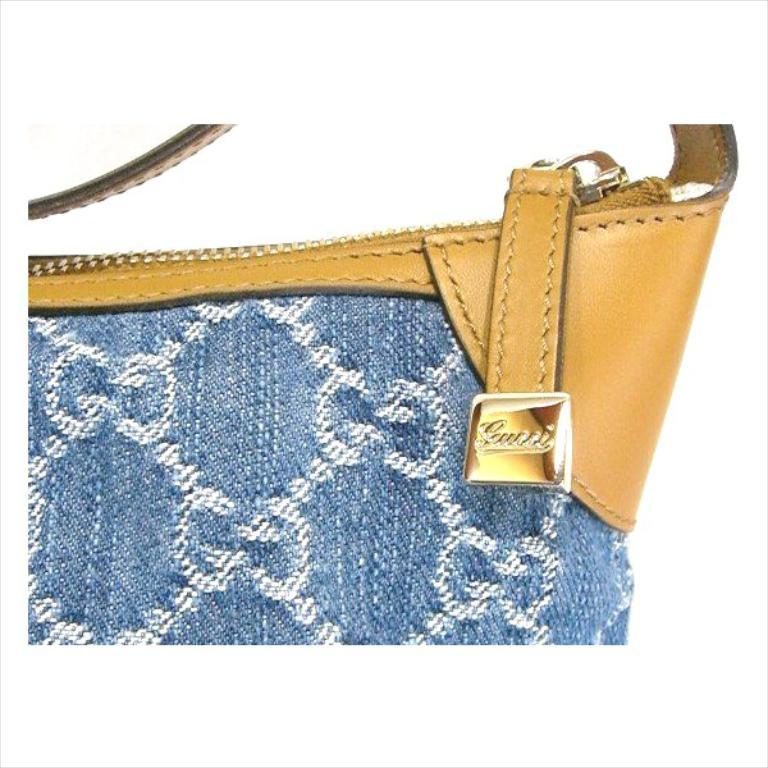What color is the bag in the image? The bag in the image is blue. Can you describe any features of the bag? Yes, there is a strap on the right side of the bag. How many dogs are sitting on the back of the bag in the image? There are no dogs present in the image, and the bag does not have a back. 